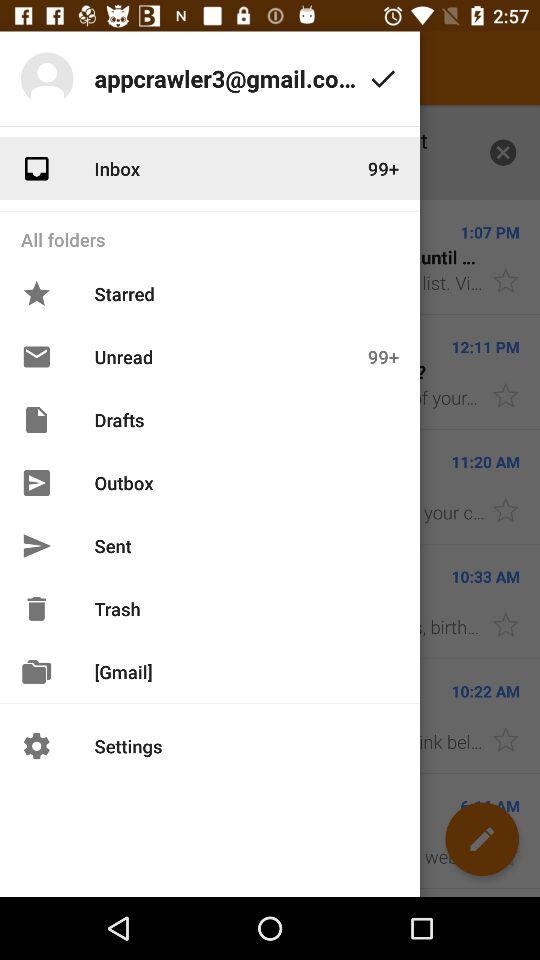How many unread emails are there in the inbox? There are more than 99 emails in the inbox. 